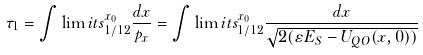<formula> <loc_0><loc_0><loc_500><loc_500>\tau _ { 1 } = \int \lim i t s _ { 1 / 1 2 } ^ { x _ { 0 } } { \frac { d x } { p _ { x } } } = \int \lim i t s _ { 1 / 1 2 } ^ { x _ { 0 } } { \frac { d x } { { \sqrt { 2 ( \varepsilon E _ { S } - U _ { Q O } ( x , 0 ) ) } } } }</formula> 